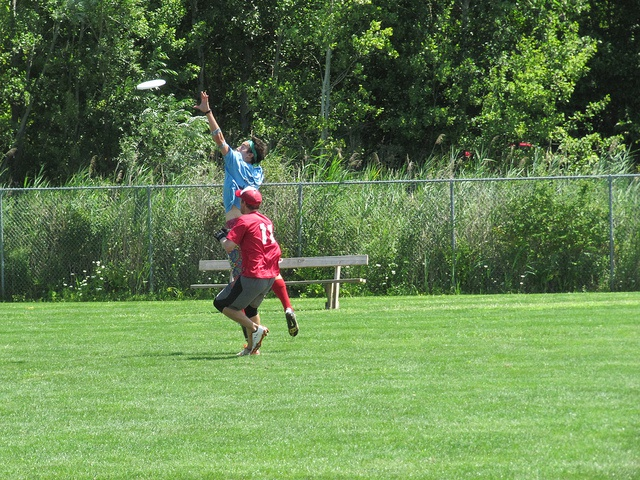Describe the objects in this image and their specific colors. I can see people in green, maroon, black, gray, and brown tones, bench in green, darkgray, darkgreen, and gray tones, people in green, teal, gray, black, and white tones, and frisbee in green, white, lightblue, darkgray, and gray tones in this image. 